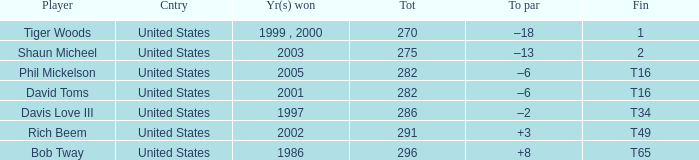In which year(s) did the person with a total greater than 286 win? 2002, 1986. 